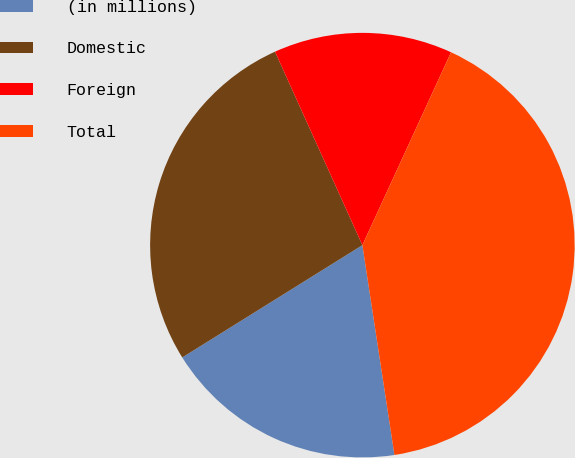<chart> <loc_0><loc_0><loc_500><loc_500><pie_chart><fcel>(in millions)<fcel>Domestic<fcel>Foreign<fcel>Total<nl><fcel>18.54%<fcel>27.12%<fcel>13.61%<fcel>40.73%<nl></chart> 